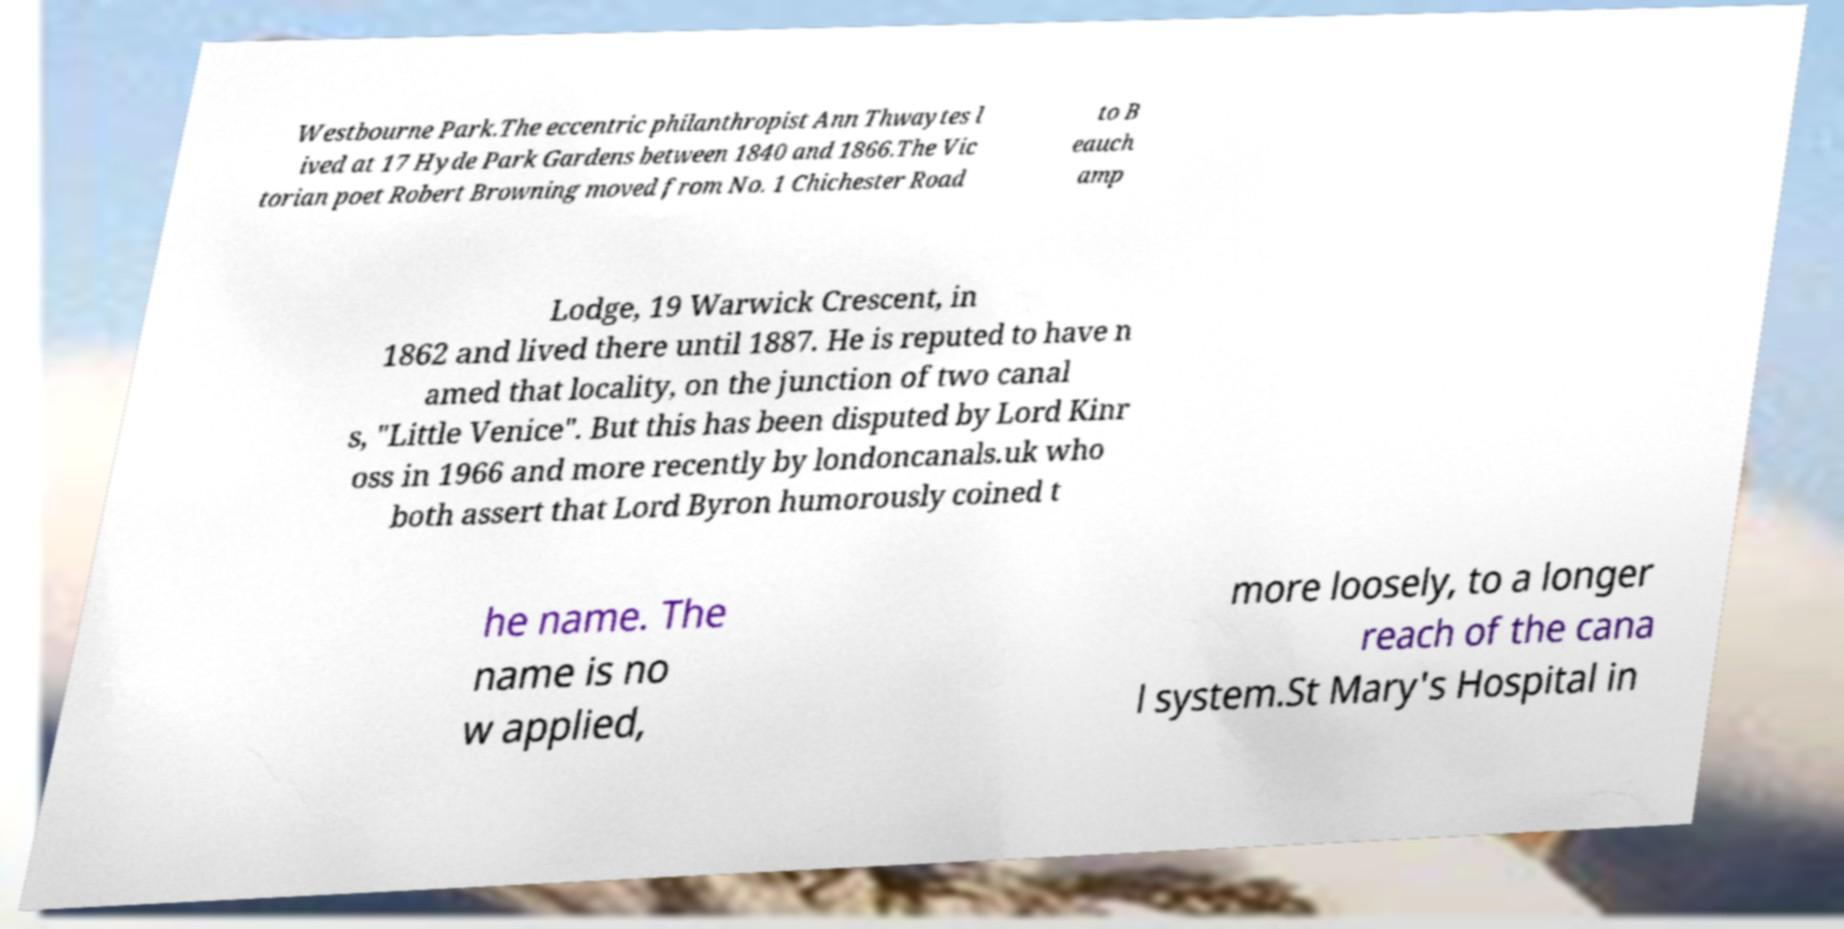Can you read and provide the text displayed in the image?This photo seems to have some interesting text. Can you extract and type it out for me? Westbourne Park.The eccentric philanthropist Ann Thwaytes l ived at 17 Hyde Park Gardens between 1840 and 1866.The Vic torian poet Robert Browning moved from No. 1 Chichester Road to B eauch amp Lodge, 19 Warwick Crescent, in 1862 and lived there until 1887. He is reputed to have n amed that locality, on the junction of two canal s, "Little Venice". But this has been disputed by Lord Kinr oss in 1966 and more recently by londoncanals.uk who both assert that Lord Byron humorously coined t he name. The name is no w applied, more loosely, to a longer reach of the cana l system.St Mary's Hospital in 